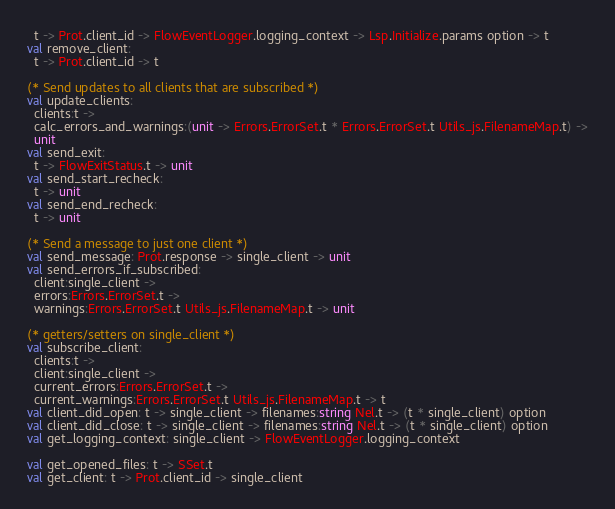Convert code to text. <code><loc_0><loc_0><loc_500><loc_500><_OCaml_>  t -> Prot.client_id -> FlowEventLogger.logging_context -> Lsp.Initialize.params option -> t
val remove_client:
  t -> Prot.client_id -> t

(* Send updates to all clients that are subscribed *)
val update_clients:
  clients:t ->
  calc_errors_and_warnings:(unit -> Errors.ErrorSet.t * Errors.ErrorSet.t Utils_js.FilenameMap.t) ->
  unit
val send_exit:
  t -> FlowExitStatus.t -> unit
val send_start_recheck:
  t -> unit
val send_end_recheck:
  t -> unit

(* Send a message to just one client *)
val send_message: Prot.response -> single_client -> unit
val send_errors_if_subscribed:
  client:single_client ->
  errors:Errors.ErrorSet.t ->
  warnings:Errors.ErrorSet.t Utils_js.FilenameMap.t -> unit

(* getters/setters on single_client *)
val subscribe_client:
  clients:t ->
  client:single_client ->
  current_errors:Errors.ErrorSet.t ->
  current_warnings:Errors.ErrorSet.t Utils_js.FilenameMap.t -> t
val client_did_open: t -> single_client -> filenames:string Nel.t -> (t * single_client) option
val client_did_close: t -> single_client -> filenames:string Nel.t -> (t * single_client) option
val get_logging_context: single_client -> FlowEventLogger.logging_context

val get_opened_files: t -> SSet.t
val get_client: t -> Prot.client_id -> single_client
</code> 